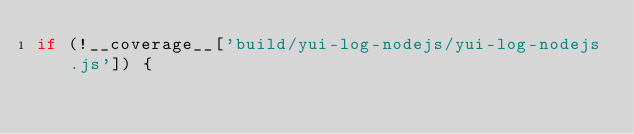Convert code to text. <code><loc_0><loc_0><loc_500><loc_500><_JavaScript_>if (!__coverage__['build/yui-log-nodejs/yui-log-nodejs.js']) {</code> 